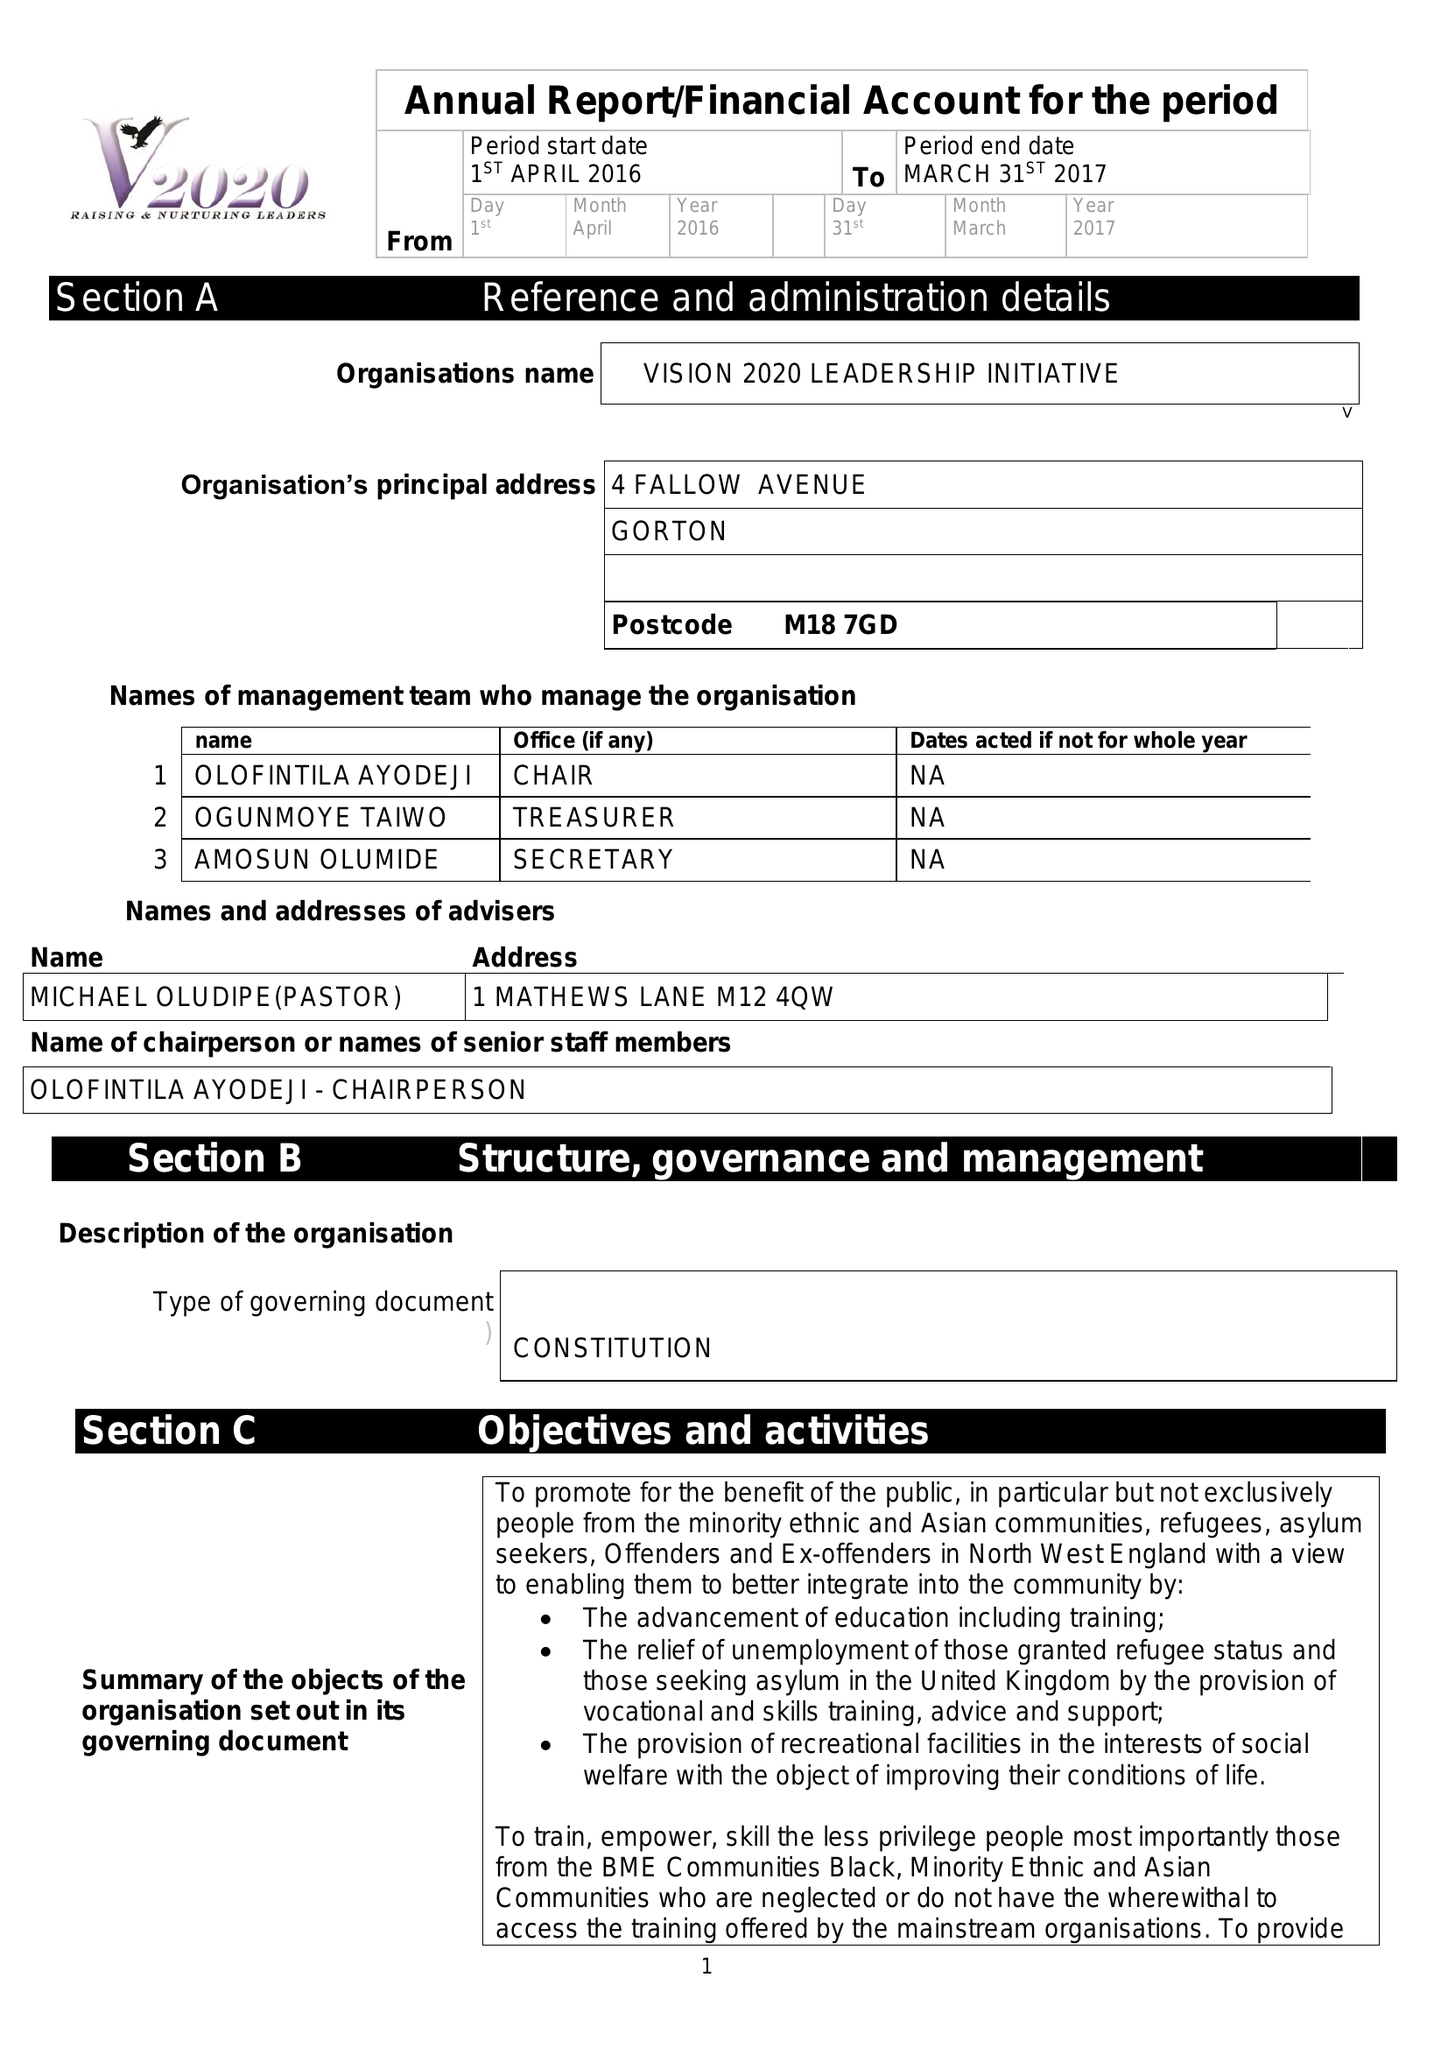What is the value for the charity_name?
Answer the question using a single word or phrase. Vision 2020 Leadership Initiative 